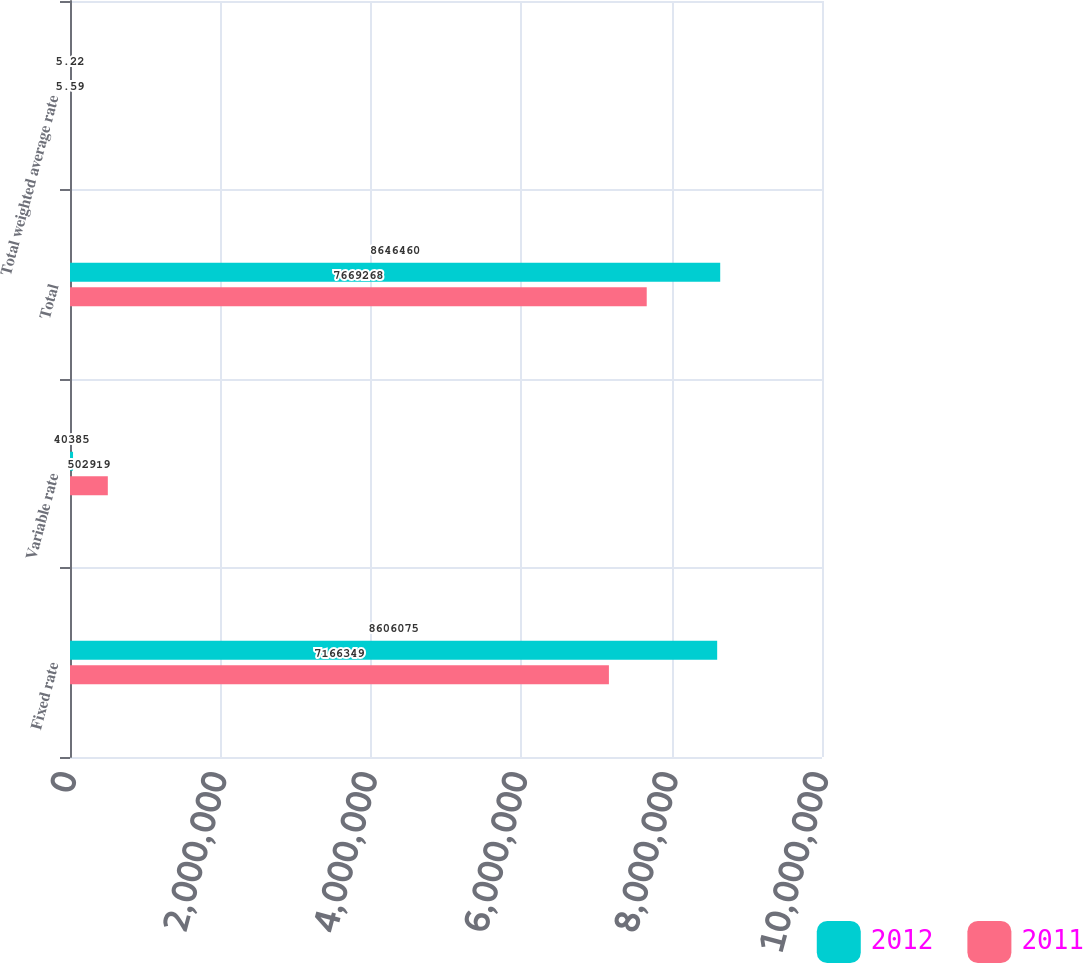<chart> <loc_0><loc_0><loc_500><loc_500><stacked_bar_chart><ecel><fcel>Fixed rate<fcel>Variable rate<fcel>Total<fcel>Total weighted average rate<nl><fcel>2012<fcel>8.60608e+06<fcel>40385<fcel>8.64646e+06<fcel>5.22<nl><fcel>2011<fcel>7.16635e+06<fcel>502919<fcel>7.66927e+06<fcel>5.59<nl></chart> 